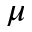<formula> <loc_0><loc_0><loc_500><loc_500>\mu</formula> 